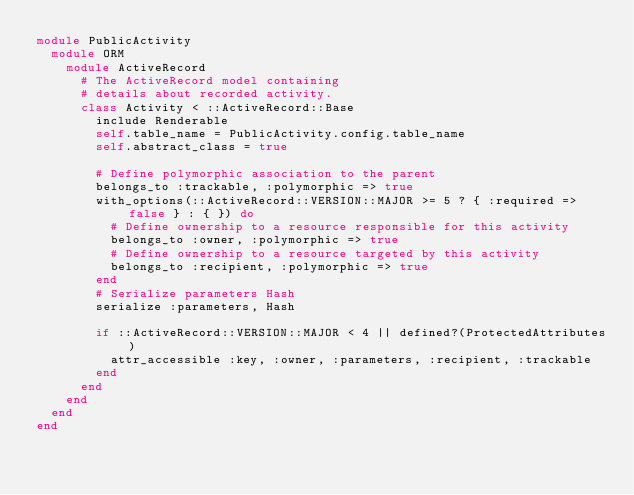<code> <loc_0><loc_0><loc_500><loc_500><_Ruby_>module PublicActivity
  module ORM
    module ActiveRecord
      # The ActiveRecord model containing
      # details about recorded activity.
      class Activity < ::ActiveRecord::Base
        include Renderable
        self.table_name = PublicActivity.config.table_name
        self.abstract_class = true

        # Define polymorphic association to the parent
        belongs_to :trackable, :polymorphic => true
        with_options(::ActiveRecord::VERSION::MAJOR >= 5 ? { :required => false } : { }) do
          # Define ownership to a resource responsible for this activity
          belongs_to :owner, :polymorphic => true
          # Define ownership to a resource targeted by this activity
          belongs_to :recipient, :polymorphic => true
        end
        # Serialize parameters Hash
        serialize :parameters, Hash

        if ::ActiveRecord::VERSION::MAJOR < 4 || defined?(ProtectedAttributes)
          attr_accessible :key, :owner, :parameters, :recipient, :trackable
        end
      end
    end
  end
end
</code> 